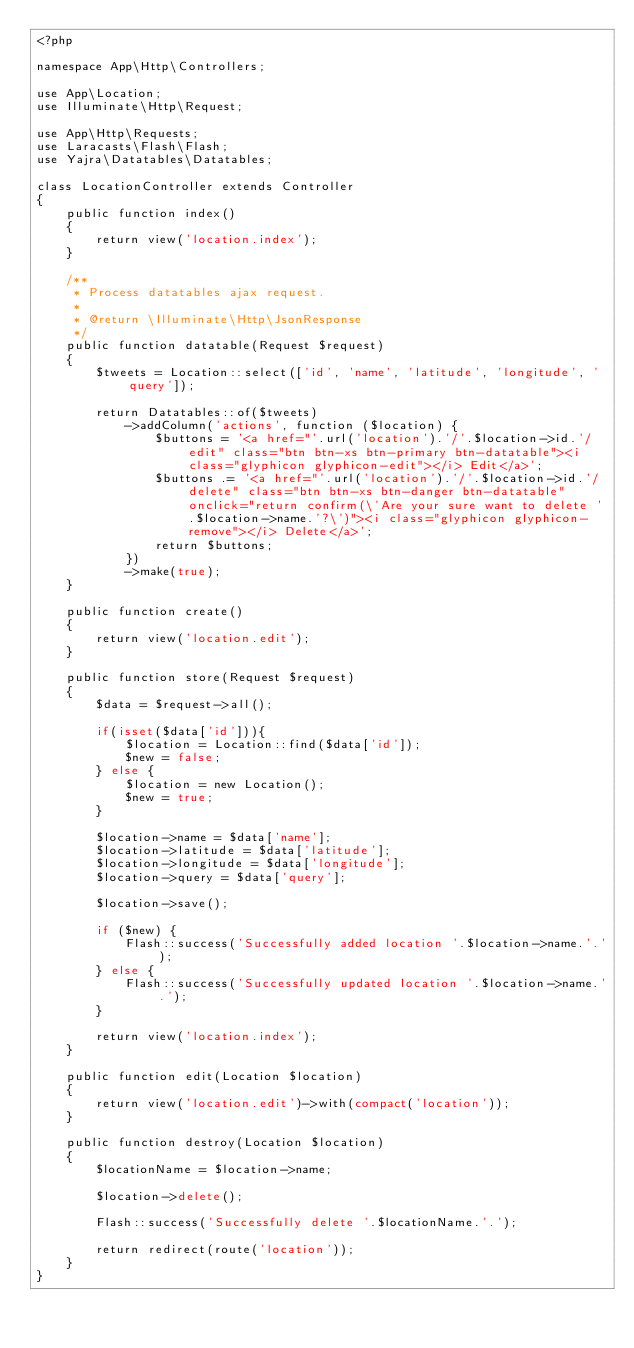Convert code to text. <code><loc_0><loc_0><loc_500><loc_500><_PHP_><?php

namespace App\Http\Controllers;

use App\Location;
use Illuminate\Http\Request;

use App\Http\Requests;
use Laracasts\Flash\Flash;
use Yajra\Datatables\Datatables;

class LocationController extends Controller
{
    public function index()
    {
        return view('location.index');
    }

    /**
     * Process datatables ajax request.
     *
     * @return \Illuminate\Http\JsonResponse
     */
    public function datatable(Request $request)
    {
        $tweets = Location::select(['id', 'name', 'latitude', 'longitude', 'query']);

        return Datatables::of($tweets)
            ->addColumn('actions', function ($location) {
                $buttons = '<a href="'.url('location').'/'.$location->id.'/edit" class="btn btn-xs btn-primary btn-datatable"><i class="glyphicon glyphicon-edit"></i> Edit</a>';
                $buttons .= '<a href="'.url('location').'/'.$location->id.'/delete" class="btn btn-xs btn-danger btn-datatable" onclick="return confirm(\'Are your sure want to delete '.$location->name.'?\')"><i class="glyphicon glyphicon-remove"></i> Delete</a>';
                return $buttons;
            })
            ->make(true);
    }

    public function create()
    {
        return view('location.edit');
    }

    public function store(Request $request)
    {
        $data = $request->all();

        if(isset($data['id'])){
            $location = Location::find($data['id']);
            $new = false;
        } else {
            $location = new Location();
            $new = true;
        }

        $location->name = $data['name'];
        $location->latitude = $data['latitude'];
        $location->longitude = $data['longitude'];
        $location->query = $data['query'];

        $location->save();

        if ($new) {
            Flash::success('Successfully added location '.$location->name.'.');
        } else {
            Flash::success('Successfully updated location '.$location->name.'.');
        }

        return view('location.index');
    }

    public function edit(Location $location)
    {
        return view('location.edit')->with(compact('location'));
    }

    public function destroy(Location $location)
    {
        $locationName = $location->name;

        $location->delete();

        Flash::success('Successfully delete '.$locationName.'.');

        return redirect(route('location'));
    }
}
</code> 